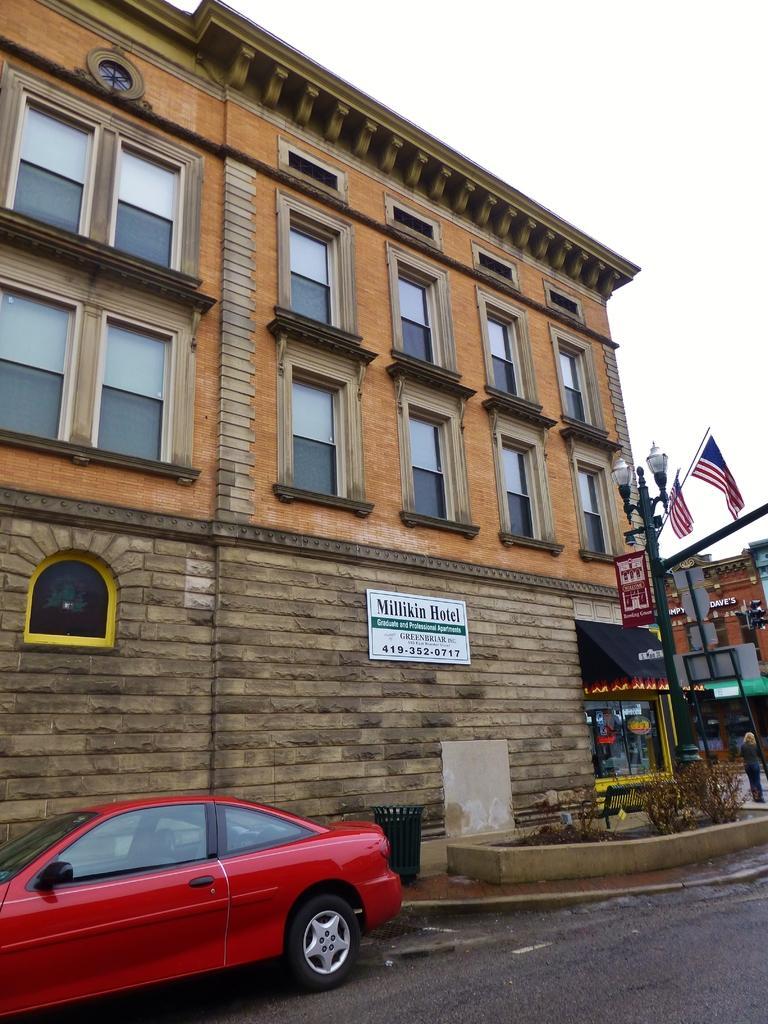How would you summarize this image in a sentence or two? In the center of the image there is a building. On the right side of the image we can see stories, flags and street lights. At the bottom of the image we can see car on the road. In the background there is sky. 